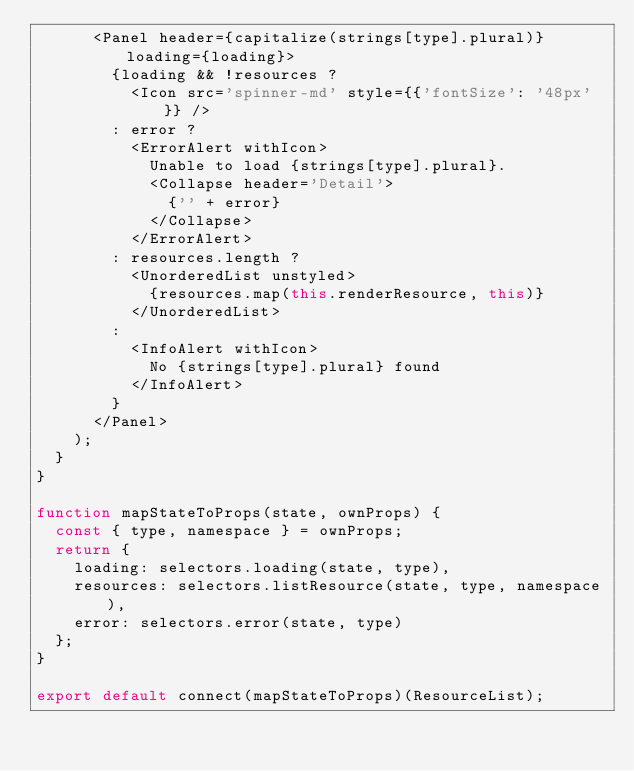<code> <loc_0><loc_0><loc_500><loc_500><_JavaScript_>      <Panel header={capitalize(strings[type].plural)} loading={loading}>
        {loading && !resources ?
          <Icon src='spinner-md' style={{'fontSize': '48px'}} />
        : error ?
          <ErrorAlert withIcon>
            Unable to load {strings[type].plural}.
            <Collapse header='Detail'>
              {'' + error}
            </Collapse>
          </ErrorAlert>
        : resources.length ?
          <UnorderedList unstyled>
            {resources.map(this.renderResource, this)}
          </UnorderedList>
        :
          <InfoAlert withIcon>
            No {strings[type].plural} found
          </InfoAlert>
        }
      </Panel>
    );
  }
}

function mapStateToProps(state, ownProps) {
  const { type, namespace } = ownProps;
  return {
    loading: selectors.loading(state, type),
    resources: selectors.listResource(state, type, namespace),
    error: selectors.error(state, type)
  };
}

export default connect(mapStateToProps)(ResourceList);
</code> 